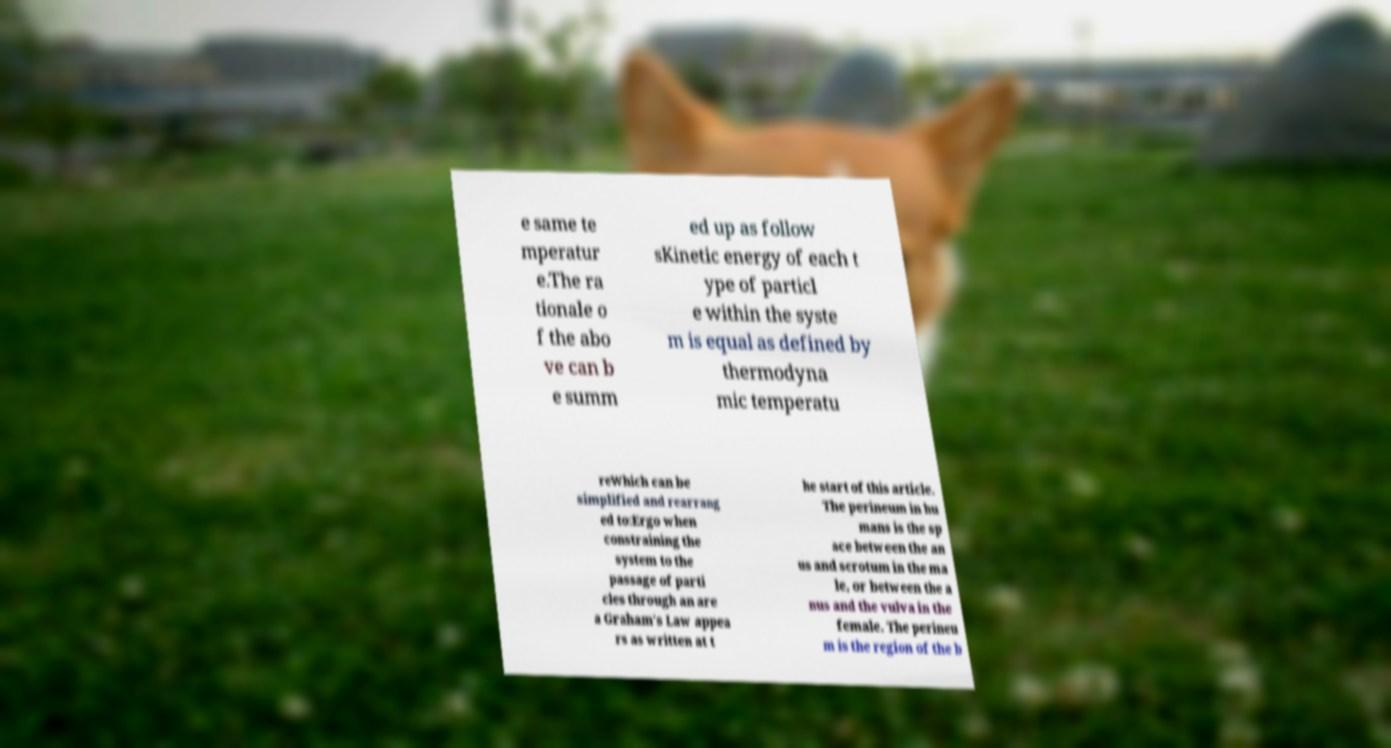Please read and relay the text visible in this image. What does it say? e same te mperatur e.The ra tionale o f the abo ve can b e summ ed up as follow sKinetic energy of each t ype of particl e within the syste m is equal as defined by thermodyna mic temperatu reWhich can be simplified and rearrang ed to:Ergo when constraining the system to the passage of parti cles through an are a Graham's Law appea rs as written at t he start of this article. The perineum in hu mans is the sp ace between the an us and scrotum in the ma le, or between the a nus and the vulva in the female. The perineu m is the region of the b 